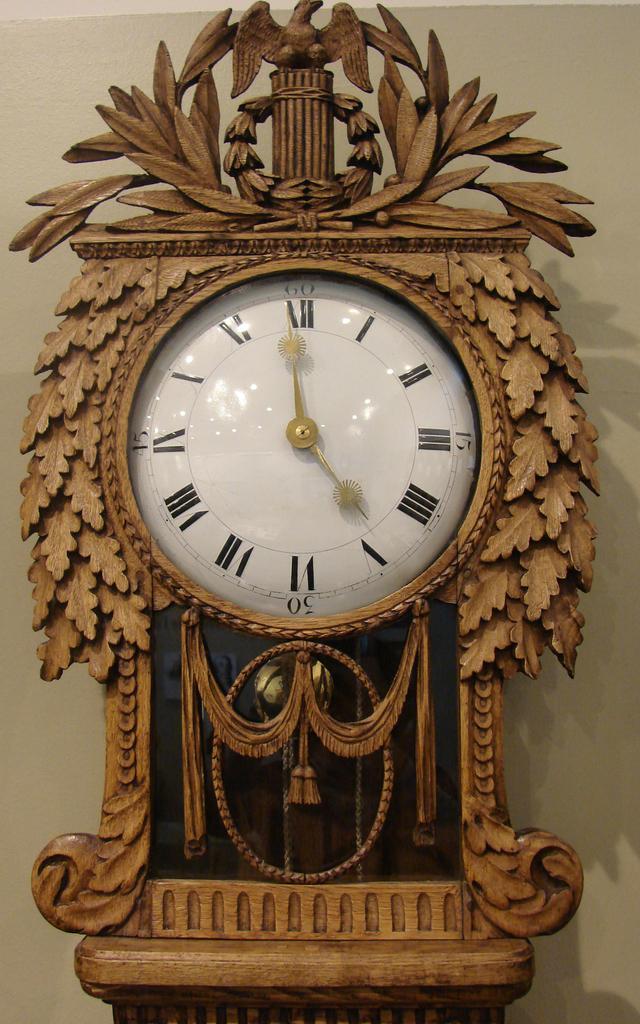How would you summarize this image in a sentence or two? In this image we can see the pendulum clock attached to the wall. 